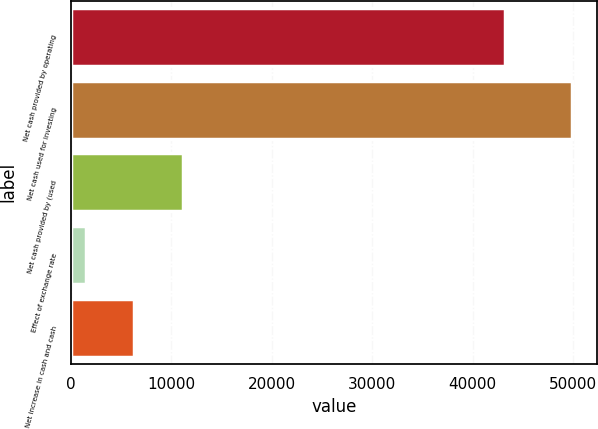Convert chart to OTSL. <chart><loc_0><loc_0><loc_500><loc_500><bar_chart><fcel>Net cash provided by operating<fcel>Net cash used for investing<fcel>Net cash provided by (used<fcel>Effect of exchange rate<fcel>Net increase in cash and cash<nl><fcel>43279<fcel>49863<fcel>11144.6<fcel>1465<fcel>6304.8<nl></chart> 